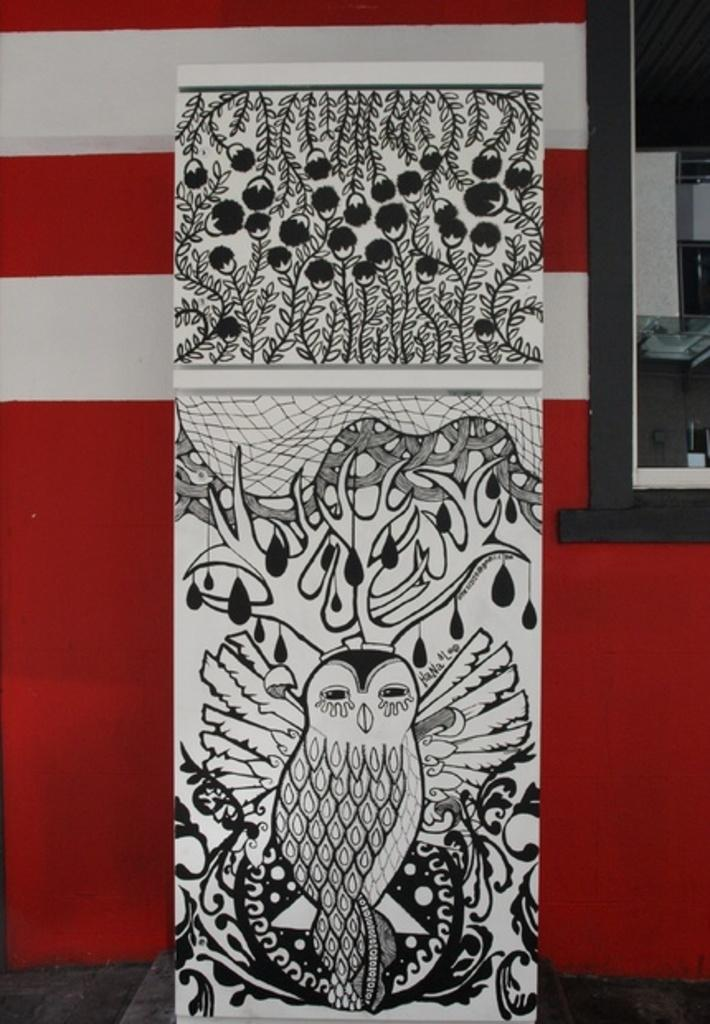What is the main subject of the image? There is an art piece in the image. What can be seen in the background of the image? There is a wall in the background of the image. Can you describe any specific features of the wall? There is a window in the wall. What type of argument is taking place between the ghosts in the image? There are no ghosts present in the image, so it is not possible to determine if an argument is taking place. 